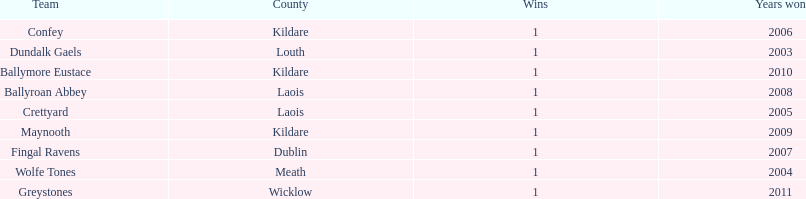Could you help me parse every detail presented in this table? {'header': ['Team', 'County', 'Wins', 'Years won'], 'rows': [['Confey', 'Kildare', '1', '2006'], ['Dundalk Gaels', 'Louth', '1', '2003'], ['Ballymore Eustace', 'Kildare', '1', '2010'], ['Ballyroan Abbey', 'Laois', '1', '2008'], ['Crettyard', 'Laois', '1', '2005'], ['Maynooth', 'Kildare', '1', '2009'], ['Fingal Ravens', 'Dublin', '1', '2007'], ['Wolfe Tones', 'Meath', '1', '2004'], ['Greystones', 'Wicklow', '1', '2011']]} Which team won after ballymore eustace? Greystones. 